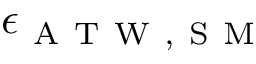<formula> <loc_0><loc_0><loc_500><loc_500>\epsilon _ { A T W , S M }</formula> 